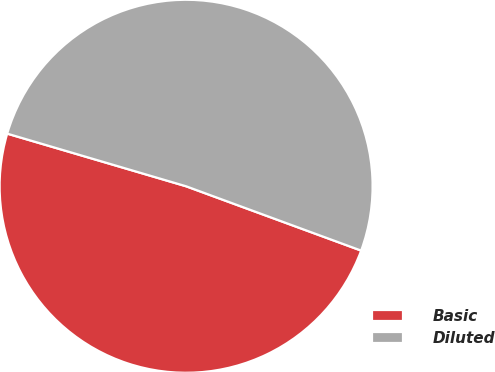Convert chart to OTSL. <chart><loc_0><loc_0><loc_500><loc_500><pie_chart><fcel>Basic<fcel>Diluted<nl><fcel>48.95%<fcel>51.05%<nl></chart> 